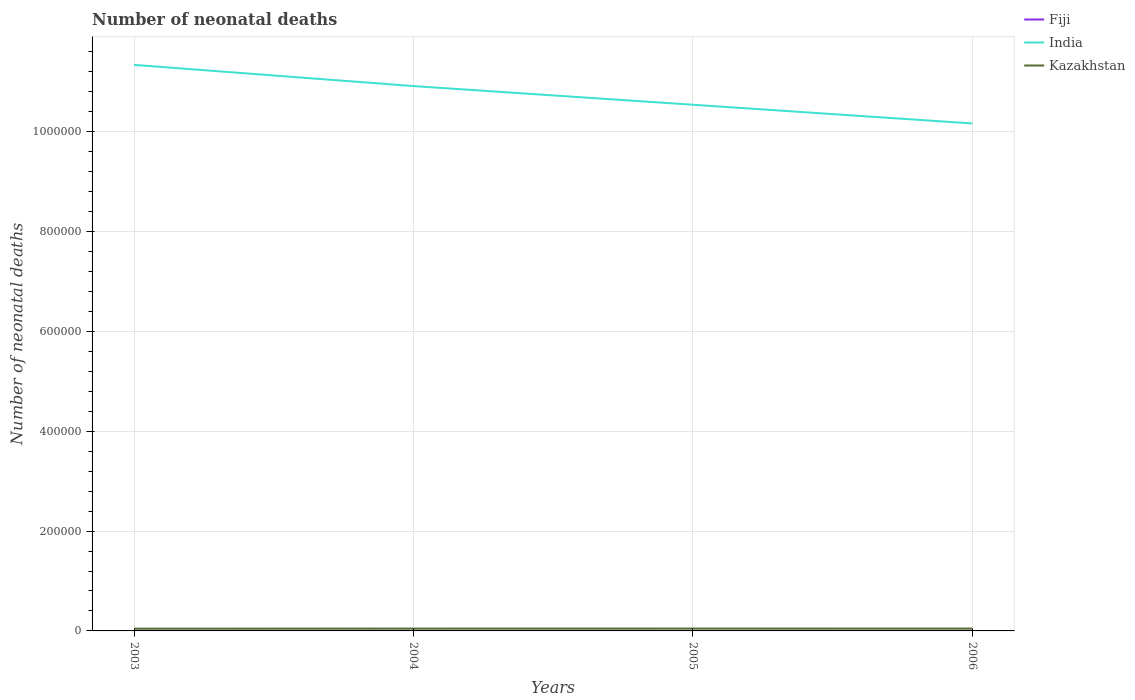How many different coloured lines are there?
Ensure brevity in your answer.  3. Does the line corresponding to India intersect with the line corresponding to Fiji?
Your response must be concise. No. Across all years, what is the maximum number of neonatal deaths in in India?
Provide a succinct answer. 1.02e+06. What is the total number of neonatal deaths in in India in the graph?
Your answer should be very brief. 1.17e+05. What is the difference between the highest and the second highest number of neonatal deaths in in Fiji?
Offer a terse response. 25. What is the difference between the highest and the lowest number of neonatal deaths in in Fiji?
Give a very brief answer. 2. Are the values on the major ticks of Y-axis written in scientific E-notation?
Your answer should be very brief. No. How many legend labels are there?
Offer a terse response. 3. How are the legend labels stacked?
Offer a terse response. Vertical. What is the title of the graph?
Offer a terse response. Number of neonatal deaths. Does "Finland" appear as one of the legend labels in the graph?
Ensure brevity in your answer.  No. What is the label or title of the X-axis?
Make the answer very short. Years. What is the label or title of the Y-axis?
Ensure brevity in your answer.  Number of neonatal deaths. What is the Number of neonatal deaths in Fiji in 2003?
Your answer should be compact. 253. What is the Number of neonatal deaths of India in 2003?
Give a very brief answer. 1.13e+06. What is the Number of neonatal deaths of Kazakhstan in 2003?
Provide a succinct answer. 4514. What is the Number of neonatal deaths of Fiji in 2004?
Your response must be concise. 248. What is the Number of neonatal deaths in India in 2004?
Give a very brief answer. 1.09e+06. What is the Number of neonatal deaths of Kazakhstan in 2004?
Offer a very short reply. 4688. What is the Number of neonatal deaths in Fiji in 2005?
Make the answer very short. 242. What is the Number of neonatal deaths of India in 2005?
Your response must be concise. 1.05e+06. What is the Number of neonatal deaths in Kazakhstan in 2005?
Provide a succinct answer. 4746. What is the Number of neonatal deaths in Fiji in 2006?
Your answer should be compact. 228. What is the Number of neonatal deaths of India in 2006?
Make the answer very short. 1.02e+06. What is the Number of neonatal deaths of Kazakhstan in 2006?
Your response must be concise. 4711. Across all years, what is the maximum Number of neonatal deaths in Fiji?
Ensure brevity in your answer.  253. Across all years, what is the maximum Number of neonatal deaths of India?
Your response must be concise. 1.13e+06. Across all years, what is the maximum Number of neonatal deaths of Kazakhstan?
Your answer should be very brief. 4746. Across all years, what is the minimum Number of neonatal deaths in Fiji?
Offer a terse response. 228. Across all years, what is the minimum Number of neonatal deaths of India?
Provide a short and direct response. 1.02e+06. Across all years, what is the minimum Number of neonatal deaths in Kazakhstan?
Keep it short and to the point. 4514. What is the total Number of neonatal deaths in Fiji in the graph?
Your answer should be compact. 971. What is the total Number of neonatal deaths of India in the graph?
Ensure brevity in your answer.  4.30e+06. What is the total Number of neonatal deaths of Kazakhstan in the graph?
Ensure brevity in your answer.  1.87e+04. What is the difference between the Number of neonatal deaths in Fiji in 2003 and that in 2004?
Offer a very short reply. 5. What is the difference between the Number of neonatal deaths of India in 2003 and that in 2004?
Provide a succinct answer. 4.25e+04. What is the difference between the Number of neonatal deaths in Kazakhstan in 2003 and that in 2004?
Offer a very short reply. -174. What is the difference between the Number of neonatal deaths in Fiji in 2003 and that in 2005?
Your answer should be very brief. 11. What is the difference between the Number of neonatal deaths of India in 2003 and that in 2005?
Your response must be concise. 7.99e+04. What is the difference between the Number of neonatal deaths in Kazakhstan in 2003 and that in 2005?
Keep it short and to the point. -232. What is the difference between the Number of neonatal deaths in Fiji in 2003 and that in 2006?
Your answer should be compact. 25. What is the difference between the Number of neonatal deaths in India in 2003 and that in 2006?
Keep it short and to the point. 1.17e+05. What is the difference between the Number of neonatal deaths in Kazakhstan in 2003 and that in 2006?
Your response must be concise. -197. What is the difference between the Number of neonatal deaths in India in 2004 and that in 2005?
Your answer should be very brief. 3.74e+04. What is the difference between the Number of neonatal deaths of Kazakhstan in 2004 and that in 2005?
Offer a terse response. -58. What is the difference between the Number of neonatal deaths in Fiji in 2004 and that in 2006?
Offer a very short reply. 20. What is the difference between the Number of neonatal deaths of India in 2004 and that in 2006?
Offer a very short reply. 7.49e+04. What is the difference between the Number of neonatal deaths of Fiji in 2005 and that in 2006?
Your answer should be very brief. 14. What is the difference between the Number of neonatal deaths in India in 2005 and that in 2006?
Make the answer very short. 3.75e+04. What is the difference between the Number of neonatal deaths of Kazakhstan in 2005 and that in 2006?
Offer a very short reply. 35. What is the difference between the Number of neonatal deaths of Fiji in 2003 and the Number of neonatal deaths of India in 2004?
Offer a very short reply. -1.09e+06. What is the difference between the Number of neonatal deaths of Fiji in 2003 and the Number of neonatal deaths of Kazakhstan in 2004?
Offer a very short reply. -4435. What is the difference between the Number of neonatal deaths of India in 2003 and the Number of neonatal deaths of Kazakhstan in 2004?
Your answer should be compact. 1.13e+06. What is the difference between the Number of neonatal deaths in Fiji in 2003 and the Number of neonatal deaths in India in 2005?
Offer a very short reply. -1.05e+06. What is the difference between the Number of neonatal deaths in Fiji in 2003 and the Number of neonatal deaths in Kazakhstan in 2005?
Your response must be concise. -4493. What is the difference between the Number of neonatal deaths of India in 2003 and the Number of neonatal deaths of Kazakhstan in 2005?
Provide a succinct answer. 1.13e+06. What is the difference between the Number of neonatal deaths of Fiji in 2003 and the Number of neonatal deaths of India in 2006?
Provide a short and direct response. -1.02e+06. What is the difference between the Number of neonatal deaths of Fiji in 2003 and the Number of neonatal deaths of Kazakhstan in 2006?
Your response must be concise. -4458. What is the difference between the Number of neonatal deaths of India in 2003 and the Number of neonatal deaths of Kazakhstan in 2006?
Keep it short and to the point. 1.13e+06. What is the difference between the Number of neonatal deaths in Fiji in 2004 and the Number of neonatal deaths in India in 2005?
Offer a terse response. -1.05e+06. What is the difference between the Number of neonatal deaths in Fiji in 2004 and the Number of neonatal deaths in Kazakhstan in 2005?
Ensure brevity in your answer.  -4498. What is the difference between the Number of neonatal deaths of India in 2004 and the Number of neonatal deaths of Kazakhstan in 2005?
Provide a short and direct response. 1.09e+06. What is the difference between the Number of neonatal deaths in Fiji in 2004 and the Number of neonatal deaths in India in 2006?
Your answer should be compact. -1.02e+06. What is the difference between the Number of neonatal deaths in Fiji in 2004 and the Number of neonatal deaths in Kazakhstan in 2006?
Give a very brief answer. -4463. What is the difference between the Number of neonatal deaths in India in 2004 and the Number of neonatal deaths in Kazakhstan in 2006?
Give a very brief answer. 1.09e+06. What is the difference between the Number of neonatal deaths in Fiji in 2005 and the Number of neonatal deaths in India in 2006?
Offer a terse response. -1.02e+06. What is the difference between the Number of neonatal deaths in Fiji in 2005 and the Number of neonatal deaths in Kazakhstan in 2006?
Provide a short and direct response. -4469. What is the difference between the Number of neonatal deaths of India in 2005 and the Number of neonatal deaths of Kazakhstan in 2006?
Your answer should be very brief. 1.05e+06. What is the average Number of neonatal deaths of Fiji per year?
Offer a terse response. 242.75. What is the average Number of neonatal deaths of India per year?
Give a very brief answer. 1.07e+06. What is the average Number of neonatal deaths of Kazakhstan per year?
Your answer should be compact. 4664.75. In the year 2003, what is the difference between the Number of neonatal deaths of Fiji and Number of neonatal deaths of India?
Offer a very short reply. -1.13e+06. In the year 2003, what is the difference between the Number of neonatal deaths of Fiji and Number of neonatal deaths of Kazakhstan?
Your response must be concise. -4261. In the year 2003, what is the difference between the Number of neonatal deaths of India and Number of neonatal deaths of Kazakhstan?
Ensure brevity in your answer.  1.13e+06. In the year 2004, what is the difference between the Number of neonatal deaths in Fiji and Number of neonatal deaths in India?
Your answer should be very brief. -1.09e+06. In the year 2004, what is the difference between the Number of neonatal deaths in Fiji and Number of neonatal deaths in Kazakhstan?
Your answer should be compact. -4440. In the year 2004, what is the difference between the Number of neonatal deaths in India and Number of neonatal deaths in Kazakhstan?
Your response must be concise. 1.09e+06. In the year 2005, what is the difference between the Number of neonatal deaths of Fiji and Number of neonatal deaths of India?
Your answer should be compact. -1.05e+06. In the year 2005, what is the difference between the Number of neonatal deaths of Fiji and Number of neonatal deaths of Kazakhstan?
Offer a very short reply. -4504. In the year 2005, what is the difference between the Number of neonatal deaths in India and Number of neonatal deaths in Kazakhstan?
Your answer should be compact. 1.05e+06. In the year 2006, what is the difference between the Number of neonatal deaths of Fiji and Number of neonatal deaths of India?
Keep it short and to the point. -1.02e+06. In the year 2006, what is the difference between the Number of neonatal deaths in Fiji and Number of neonatal deaths in Kazakhstan?
Your answer should be very brief. -4483. In the year 2006, what is the difference between the Number of neonatal deaths in India and Number of neonatal deaths in Kazakhstan?
Provide a succinct answer. 1.01e+06. What is the ratio of the Number of neonatal deaths of Fiji in 2003 to that in 2004?
Provide a succinct answer. 1.02. What is the ratio of the Number of neonatal deaths in India in 2003 to that in 2004?
Keep it short and to the point. 1.04. What is the ratio of the Number of neonatal deaths in Kazakhstan in 2003 to that in 2004?
Keep it short and to the point. 0.96. What is the ratio of the Number of neonatal deaths of Fiji in 2003 to that in 2005?
Offer a terse response. 1.05. What is the ratio of the Number of neonatal deaths of India in 2003 to that in 2005?
Make the answer very short. 1.08. What is the ratio of the Number of neonatal deaths of Kazakhstan in 2003 to that in 2005?
Keep it short and to the point. 0.95. What is the ratio of the Number of neonatal deaths of Fiji in 2003 to that in 2006?
Offer a terse response. 1.11. What is the ratio of the Number of neonatal deaths of India in 2003 to that in 2006?
Your answer should be compact. 1.12. What is the ratio of the Number of neonatal deaths of Kazakhstan in 2003 to that in 2006?
Provide a succinct answer. 0.96. What is the ratio of the Number of neonatal deaths of Fiji in 2004 to that in 2005?
Keep it short and to the point. 1.02. What is the ratio of the Number of neonatal deaths in India in 2004 to that in 2005?
Provide a short and direct response. 1.04. What is the ratio of the Number of neonatal deaths in Kazakhstan in 2004 to that in 2005?
Make the answer very short. 0.99. What is the ratio of the Number of neonatal deaths in Fiji in 2004 to that in 2006?
Provide a short and direct response. 1.09. What is the ratio of the Number of neonatal deaths in India in 2004 to that in 2006?
Ensure brevity in your answer.  1.07. What is the ratio of the Number of neonatal deaths of Kazakhstan in 2004 to that in 2006?
Provide a short and direct response. 1. What is the ratio of the Number of neonatal deaths of Fiji in 2005 to that in 2006?
Offer a terse response. 1.06. What is the ratio of the Number of neonatal deaths in India in 2005 to that in 2006?
Your answer should be compact. 1.04. What is the ratio of the Number of neonatal deaths of Kazakhstan in 2005 to that in 2006?
Keep it short and to the point. 1.01. What is the difference between the highest and the second highest Number of neonatal deaths of India?
Keep it short and to the point. 4.25e+04. What is the difference between the highest and the lowest Number of neonatal deaths in Fiji?
Offer a very short reply. 25. What is the difference between the highest and the lowest Number of neonatal deaths in India?
Make the answer very short. 1.17e+05. What is the difference between the highest and the lowest Number of neonatal deaths in Kazakhstan?
Offer a very short reply. 232. 